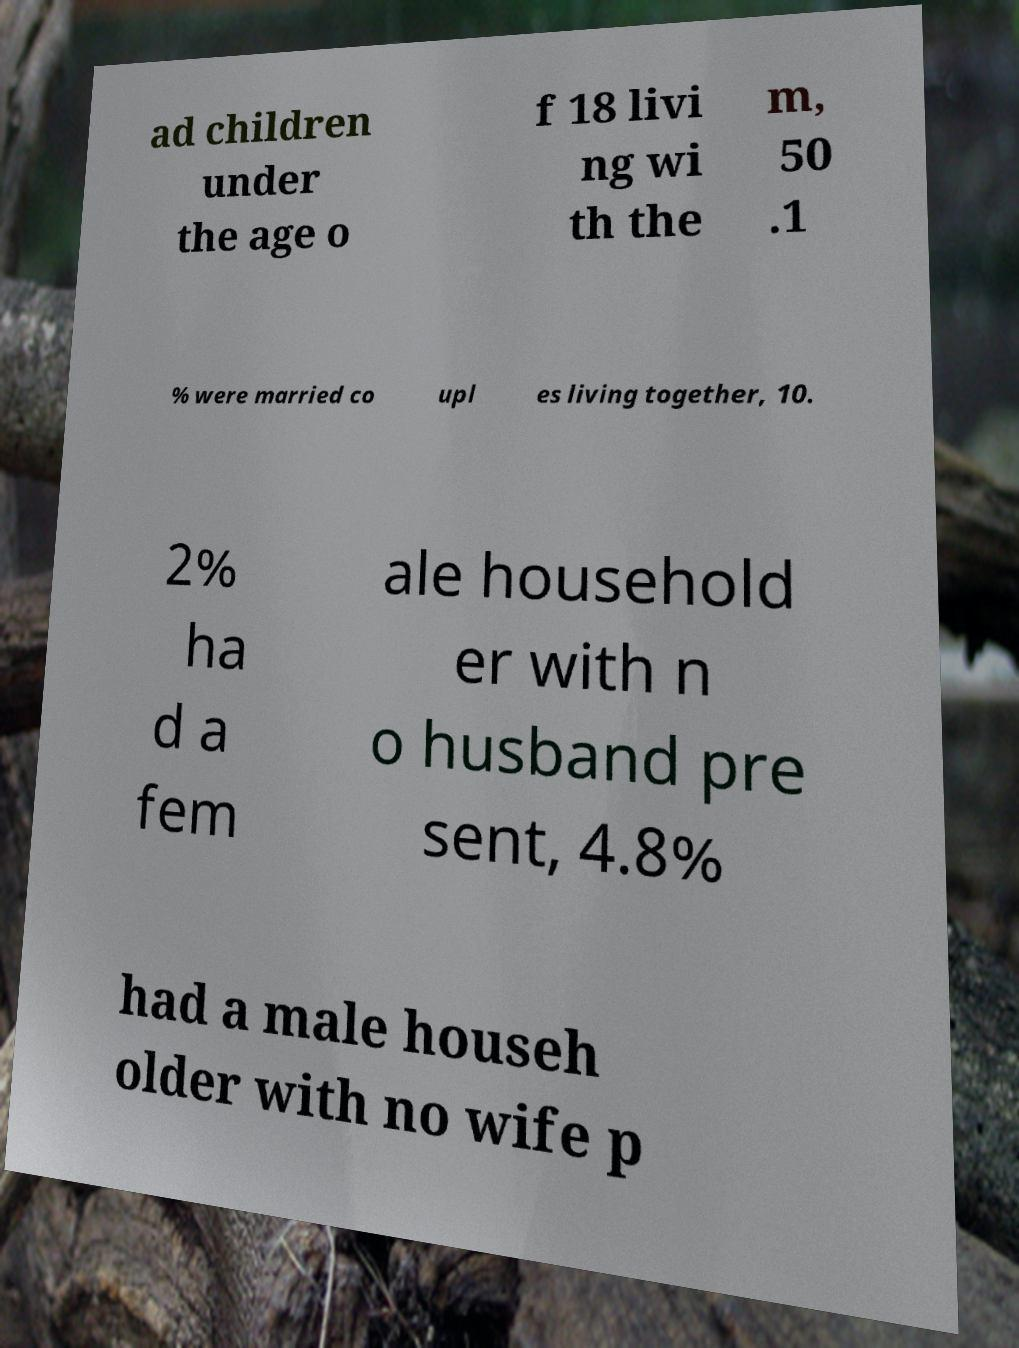For documentation purposes, I need the text within this image transcribed. Could you provide that? ad children under the age o f 18 livi ng wi th the m, 50 .1 % were married co upl es living together, 10. 2% ha d a fem ale household er with n o husband pre sent, 4.8% had a male househ older with no wife p 